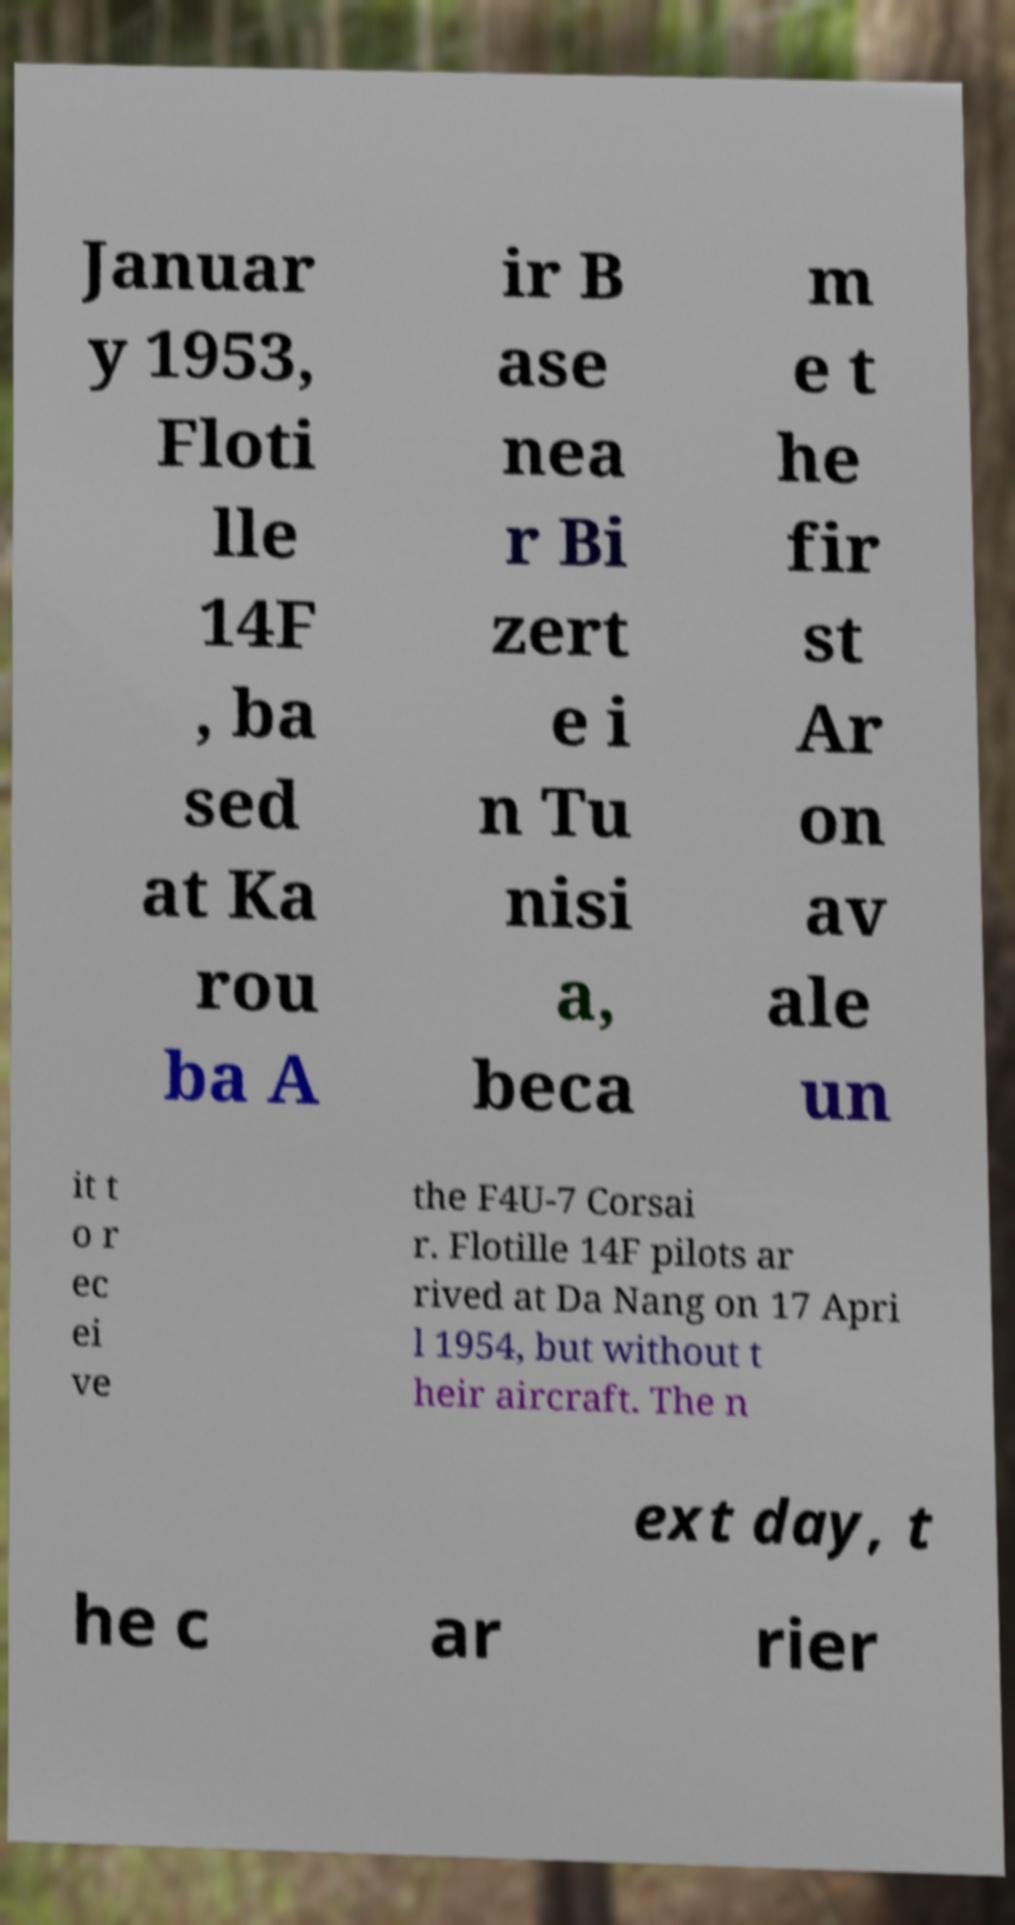Can you accurately transcribe the text from the provided image for me? Januar y 1953, Floti lle 14F , ba sed at Ka rou ba A ir B ase nea r Bi zert e i n Tu nisi a, beca m e t he fir st Ar on av ale un it t o r ec ei ve the F4U-7 Corsai r. Flotille 14F pilots ar rived at Da Nang on 17 Apri l 1954, but without t heir aircraft. The n ext day, t he c ar rier 